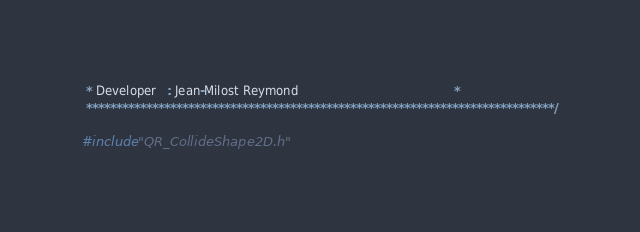<code> <loc_0><loc_0><loc_500><loc_500><_C++_> * Developer   : Jean-Milost Reymond                                          *
 ******************************************************************************/

#include "QR_CollideShape2D.h"
</code> 